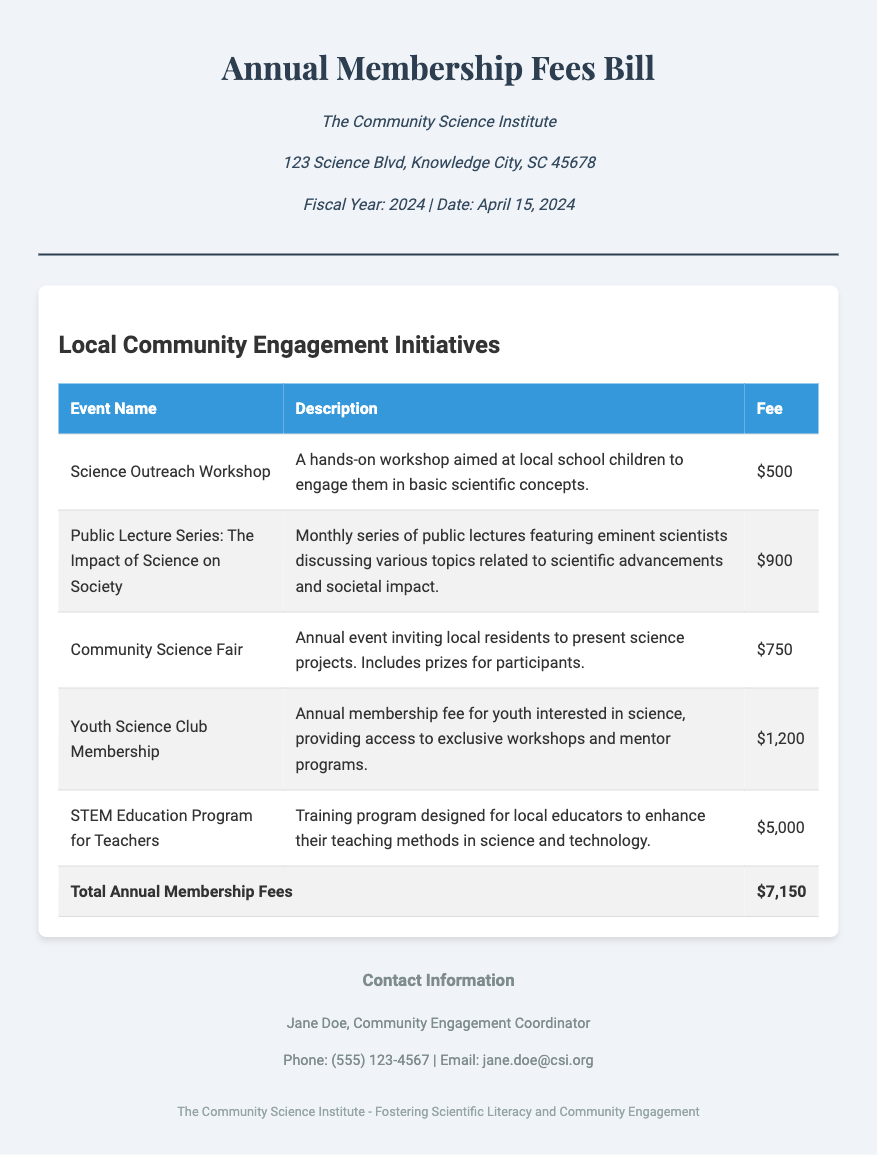What is the total annual membership fee? The total annual membership fee is listed at the bottom of the document in the fee table.
Answer: $7,150 Who is the Community Engagement Coordinator? The document includes the name of the Community Engagement Coordinator in the contact information section.
Answer: Jane Doe What is the fee for the STEM Education Program for Teachers? The fee for this specific program is provided in the table of fees.
Answer: $5,000 What type of program is the Youth Science Club Membership? The description in the fee table indicates what this membership entails.
Answer: Membership How many events are listed in the fee table? The number of events can be determined by counting the rows in the table excluding the total row.
Answer: 5 What is the description of the Science Outreach Workshop? The description is provided in the second column of the table next to the event name.
Answer: A hands-on workshop aimed at local school children to engage them in basic scientific concepts When is the date of the bill? The document states the date in the header section.
Answer: April 15, 2024 How much is the fee for the Community Science Fair? The fee for this event is mentioned in the body of the fee table.
Answer: $750 